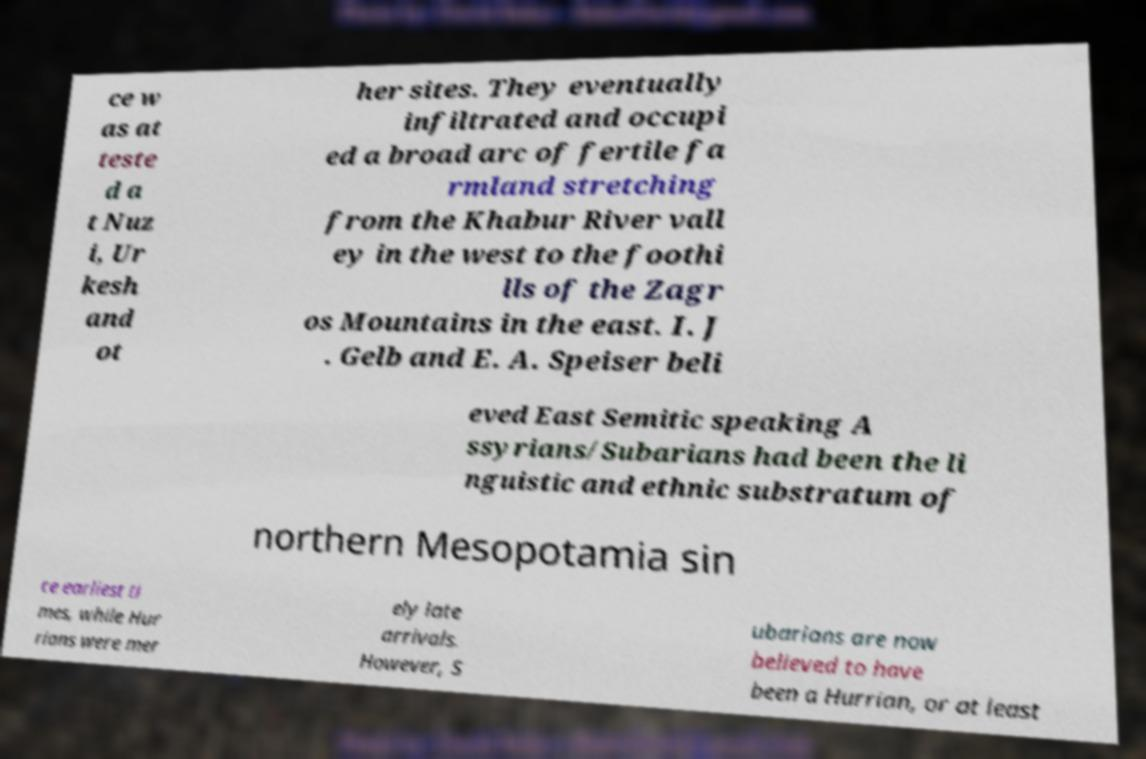Could you assist in decoding the text presented in this image and type it out clearly? ce w as at teste d a t Nuz i, Ur kesh and ot her sites. They eventually infiltrated and occupi ed a broad arc of fertile fa rmland stretching from the Khabur River vall ey in the west to the foothi lls of the Zagr os Mountains in the east. I. J . Gelb and E. A. Speiser beli eved East Semitic speaking A ssyrians/Subarians had been the li nguistic and ethnic substratum of northern Mesopotamia sin ce earliest ti mes, while Hur rians were mer ely late arrivals. However, S ubarians are now believed to have been a Hurrian, or at least 